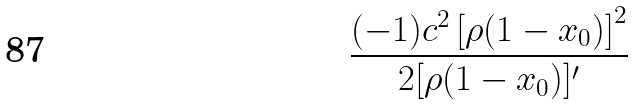<formula> <loc_0><loc_0><loc_500><loc_500>\frac { ( - 1 ) c ^ { 2 } \left [ \rho ( 1 - x _ { 0 } ) \right ] ^ { 2 } } { 2 [ \rho ( 1 - x _ { 0 } ) ] ^ { \prime } }</formula> 